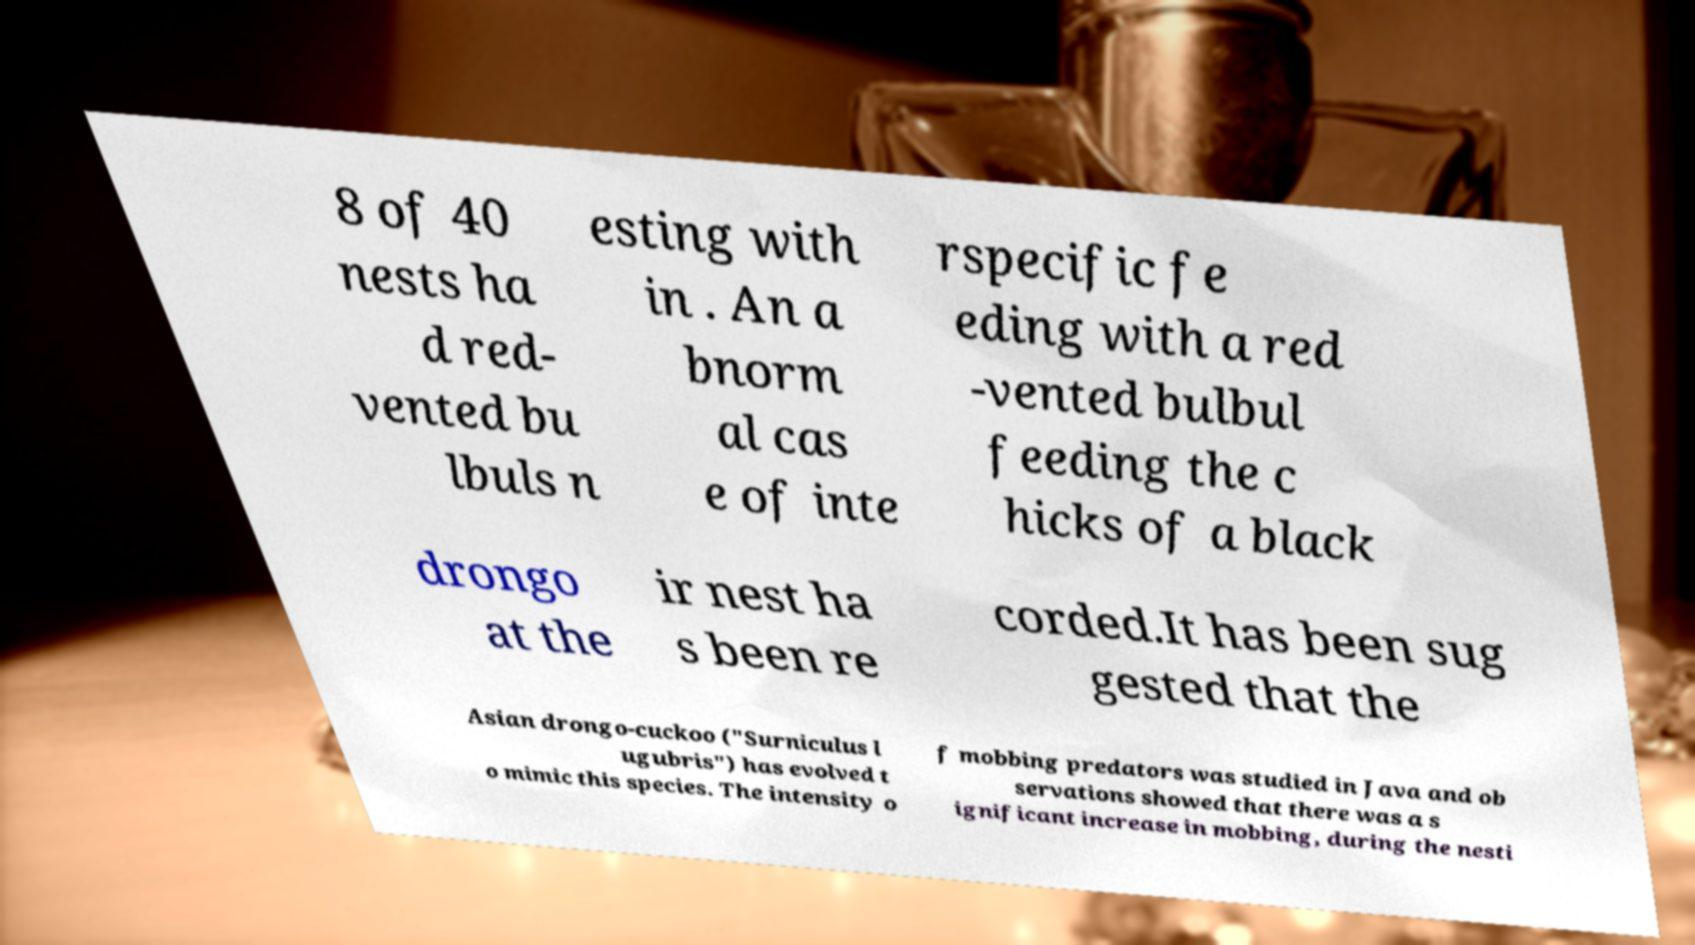Can you read and provide the text displayed in the image?This photo seems to have some interesting text. Can you extract and type it out for me? 8 of 40 nests ha d red- vented bu lbuls n esting with in . An a bnorm al cas e of inte rspecific fe eding with a red -vented bulbul feeding the c hicks of a black drongo at the ir nest ha s been re corded.It has been sug gested that the Asian drongo-cuckoo ("Surniculus l ugubris") has evolved t o mimic this species. The intensity o f mobbing predators was studied in Java and ob servations showed that there was a s ignificant increase in mobbing, during the nesti 